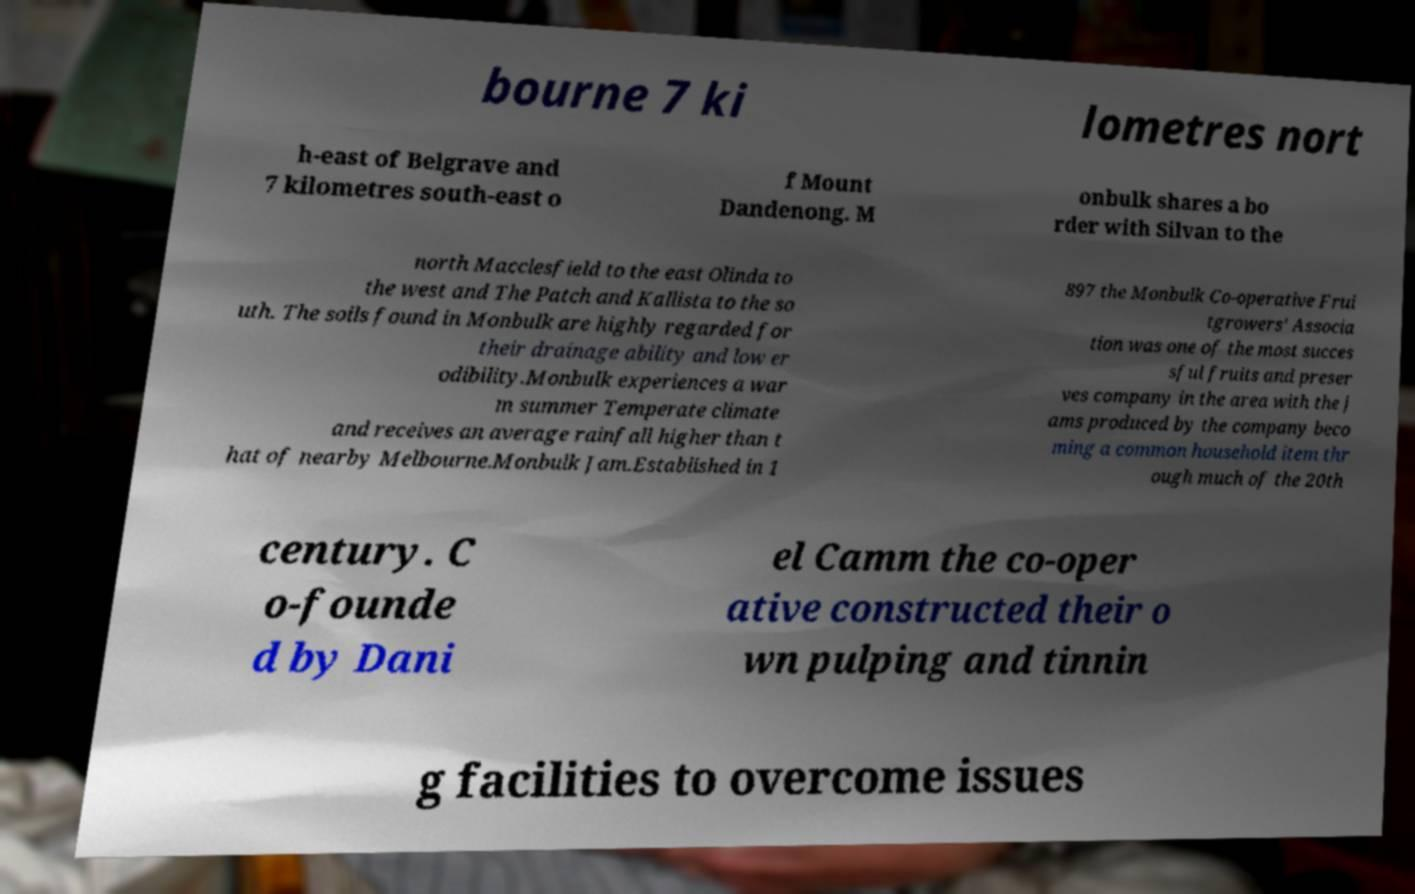Can you read and provide the text displayed in the image?This photo seems to have some interesting text. Can you extract and type it out for me? bourne 7 ki lometres nort h-east of Belgrave and 7 kilometres south-east o f Mount Dandenong. M onbulk shares a bo rder with Silvan to the north Macclesfield to the east Olinda to the west and The Patch and Kallista to the so uth. The soils found in Monbulk are highly regarded for their drainage ability and low er odibility.Monbulk experiences a war m summer Temperate climate and receives an average rainfall higher than t hat of nearby Melbourne.Monbulk Jam.Established in 1 897 the Monbulk Co-operative Frui tgrowers' Associa tion was one of the most succes sful fruits and preser ves company in the area with the j ams produced by the company beco ming a common household item thr ough much of the 20th century. C o-founde d by Dani el Camm the co-oper ative constructed their o wn pulping and tinnin g facilities to overcome issues 